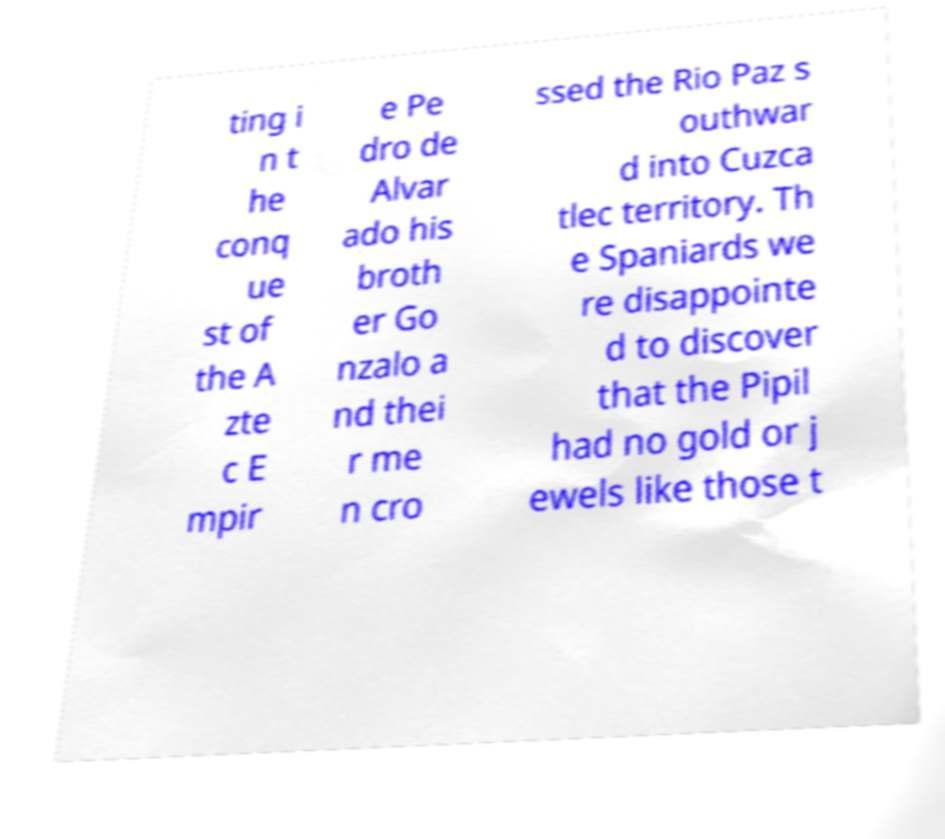Could you assist in decoding the text presented in this image and type it out clearly? ting i n t he conq ue st of the A zte c E mpir e Pe dro de Alvar ado his broth er Go nzalo a nd thei r me n cro ssed the Rio Paz s outhwar d into Cuzca tlec territory. Th e Spaniards we re disappointe d to discover that the Pipil had no gold or j ewels like those t 